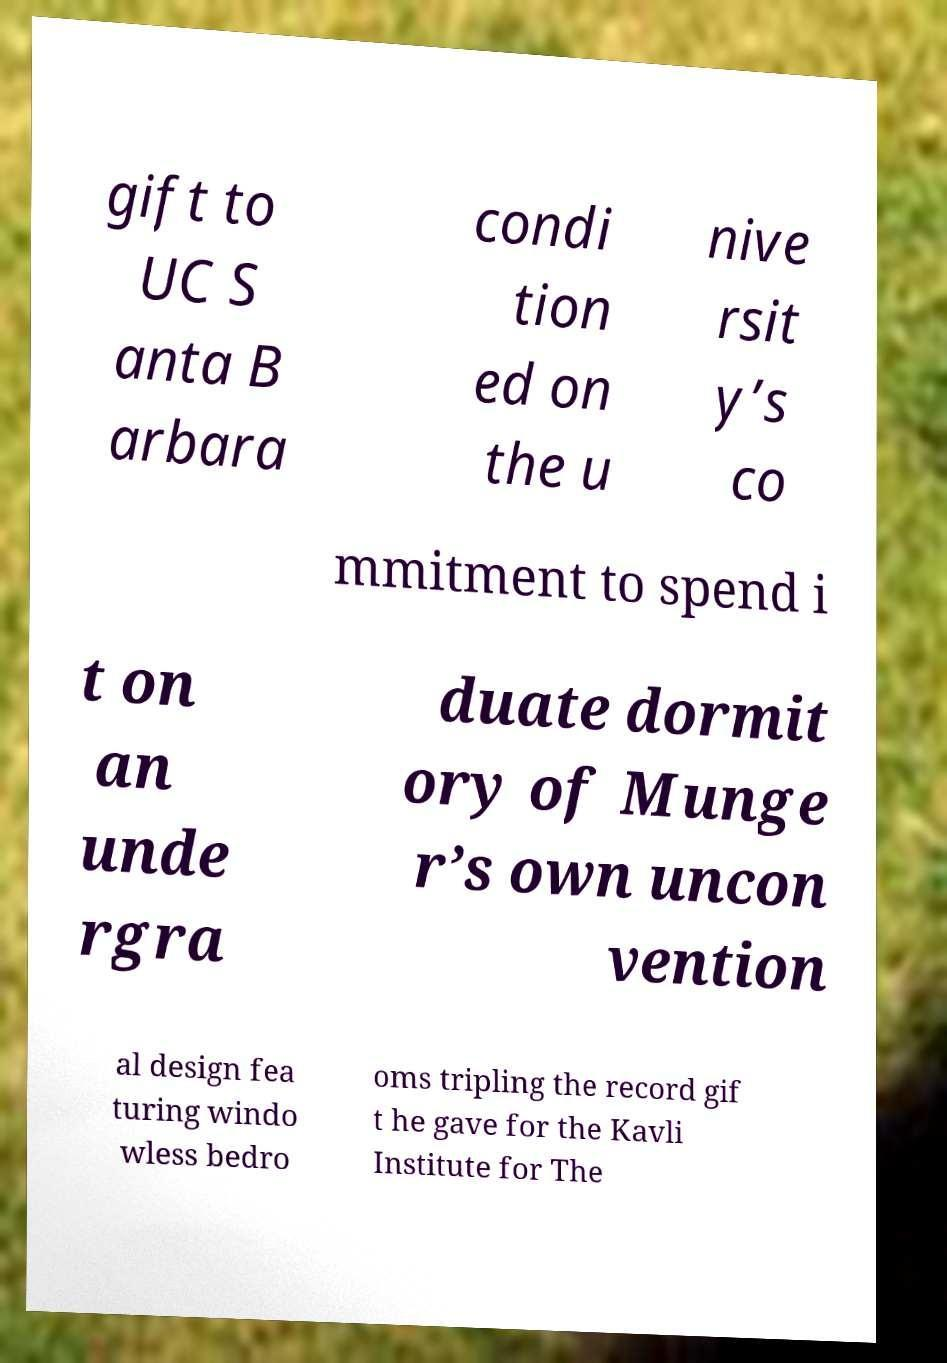Please read and relay the text visible in this image. What does it say? gift to UC S anta B arbara condi tion ed on the u nive rsit y’s co mmitment to spend i t on an unde rgra duate dormit ory of Munge r’s own uncon vention al design fea turing windo wless bedro oms tripling the record gif t he gave for the Kavli Institute for The 